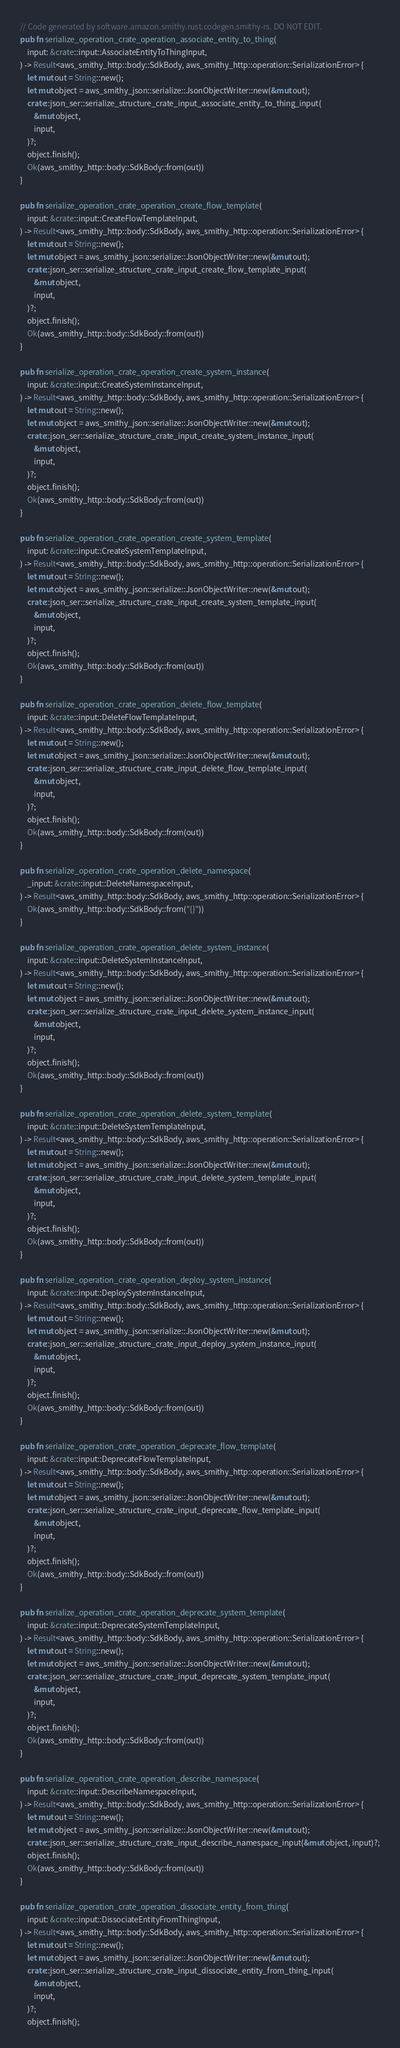<code> <loc_0><loc_0><loc_500><loc_500><_Rust_>// Code generated by software.amazon.smithy.rust.codegen.smithy-rs. DO NOT EDIT.
pub fn serialize_operation_crate_operation_associate_entity_to_thing(
    input: &crate::input::AssociateEntityToThingInput,
) -> Result<aws_smithy_http::body::SdkBody, aws_smithy_http::operation::SerializationError> {
    let mut out = String::new();
    let mut object = aws_smithy_json::serialize::JsonObjectWriter::new(&mut out);
    crate::json_ser::serialize_structure_crate_input_associate_entity_to_thing_input(
        &mut object,
        input,
    )?;
    object.finish();
    Ok(aws_smithy_http::body::SdkBody::from(out))
}

pub fn serialize_operation_crate_operation_create_flow_template(
    input: &crate::input::CreateFlowTemplateInput,
) -> Result<aws_smithy_http::body::SdkBody, aws_smithy_http::operation::SerializationError> {
    let mut out = String::new();
    let mut object = aws_smithy_json::serialize::JsonObjectWriter::new(&mut out);
    crate::json_ser::serialize_structure_crate_input_create_flow_template_input(
        &mut object,
        input,
    )?;
    object.finish();
    Ok(aws_smithy_http::body::SdkBody::from(out))
}

pub fn serialize_operation_crate_operation_create_system_instance(
    input: &crate::input::CreateSystemInstanceInput,
) -> Result<aws_smithy_http::body::SdkBody, aws_smithy_http::operation::SerializationError> {
    let mut out = String::new();
    let mut object = aws_smithy_json::serialize::JsonObjectWriter::new(&mut out);
    crate::json_ser::serialize_structure_crate_input_create_system_instance_input(
        &mut object,
        input,
    )?;
    object.finish();
    Ok(aws_smithy_http::body::SdkBody::from(out))
}

pub fn serialize_operation_crate_operation_create_system_template(
    input: &crate::input::CreateSystemTemplateInput,
) -> Result<aws_smithy_http::body::SdkBody, aws_smithy_http::operation::SerializationError> {
    let mut out = String::new();
    let mut object = aws_smithy_json::serialize::JsonObjectWriter::new(&mut out);
    crate::json_ser::serialize_structure_crate_input_create_system_template_input(
        &mut object,
        input,
    )?;
    object.finish();
    Ok(aws_smithy_http::body::SdkBody::from(out))
}

pub fn serialize_operation_crate_operation_delete_flow_template(
    input: &crate::input::DeleteFlowTemplateInput,
) -> Result<aws_smithy_http::body::SdkBody, aws_smithy_http::operation::SerializationError> {
    let mut out = String::new();
    let mut object = aws_smithy_json::serialize::JsonObjectWriter::new(&mut out);
    crate::json_ser::serialize_structure_crate_input_delete_flow_template_input(
        &mut object,
        input,
    )?;
    object.finish();
    Ok(aws_smithy_http::body::SdkBody::from(out))
}

pub fn serialize_operation_crate_operation_delete_namespace(
    _input: &crate::input::DeleteNamespaceInput,
) -> Result<aws_smithy_http::body::SdkBody, aws_smithy_http::operation::SerializationError> {
    Ok(aws_smithy_http::body::SdkBody::from("{}"))
}

pub fn serialize_operation_crate_operation_delete_system_instance(
    input: &crate::input::DeleteSystemInstanceInput,
) -> Result<aws_smithy_http::body::SdkBody, aws_smithy_http::operation::SerializationError> {
    let mut out = String::new();
    let mut object = aws_smithy_json::serialize::JsonObjectWriter::new(&mut out);
    crate::json_ser::serialize_structure_crate_input_delete_system_instance_input(
        &mut object,
        input,
    )?;
    object.finish();
    Ok(aws_smithy_http::body::SdkBody::from(out))
}

pub fn serialize_operation_crate_operation_delete_system_template(
    input: &crate::input::DeleteSystemTemplateInput,
) -> Result<aws_smithy_http::body::SdkBody, aws_smithy_http::operation::SerializationError> {
    let mut out = String::new();
    let mut object = aws_smithy_json::serialize::JsonObjectWriter::new(&mut out);
    crate::json_ser::serialize_structure_crate_input_delete_system_template_input(
        &mut object,
        input,
    )?;
    object.finish();
    Ok(aws_smithy_http::body::SdkBody::from(out))
}

pub fn serialize_operation_crate_operation_deploy_system_instance(
    input: &crate::input::DeploySystemInstanceInput,
) -> Result<aws_smithy_http::body::SdkBody, aws_smithy_http::operation::SerializationError> {
    let mut out = String::new();
    let mut object = aws_smithy_json::serialize::JsonObjectWriter::new(&mut out);
    crate::json_ser::serialize_structure_crate_input_deploy_system_instance_input(
        &mut object,
        input,
    )?;
    object.finish();
    Ok(aws_smithy_http::body::SdkBody::from(out))
}

pub fn serialize_operation_crate_operation_deprecate_flow_template(
    input: &crate::input::DeprecateFlowTemplateInput,
) -> Result<aws_smithy_http::body::SdkBody, aws_smithy_http::operation::SerializationError> {
    let mut out = String::new();
    let mut object = aws_smithy_json::serialize::JsonObjectWriter::new(&mut out);
    crate::json_ser::serialize_structure_crate_input_deprecate_flow_template_input(
        &mut object,
        input,
    )?;
    object.finish();
    Ok(aws_smithy_http::body::SdkBody::from(out))
}

pub fn serialize_operation_crate_operation_deprecate_system_template(
    input: &crate::input::DeprecateSystemTemplateInput,
) -> Result<aws_smithy_http::body::SdkBody, aws_smithy_http::operation::SerializationError> {
    let mut out = String::new();
    let mut object = aws_smithy_json::serialize::JsonObjectWriter::new(&mut out);
    crate::json_ser::serialize_structure_crate_input_deprecate_system_template_input(
        &mut object,
        input,
    )?;
    object.finish();
    Ok(aws_smithy_http::body::SdkBody::from(out))
}

pub fn serialize_operation_crate_operation_describe_namespace(
    input: &crate::input::DescribeNamespaceInput,
) -> Result<aws_smithy_http::body::SdkBody, aws_smithy_http::operation::SerializationError> {
    let mut out = String::new();
    let mut object = aws_smithy_json::serialize::JsonObjectWriter::new(&mut out);
    crate::json_ser::serialize_structure_crate_input_describe_namespace_input(&mut object, input)?;
    object.finish();
    Ok(aws_smithy_http::body::SdkBody::from(out))
}

pub fn serialize_operation_crate_operation_dissociate_entity_from_thing(
    input: &crate::input::DissociateEntityFromThingInput,
) -> Result<aws_smithy_http::body::SdkBody, aws_smithy_http::operation::SerializationError> {
    let mut out = String::new();
    let mut object = aws_smithy_json::serialize::JsonObjectWriter::new(&mut out);
    crate::json_ser::serialize_structure_crate_input_dissociate_entity_from_thing_input(
        &mut object,
        input,
    )?;
    object.finish();</code> 